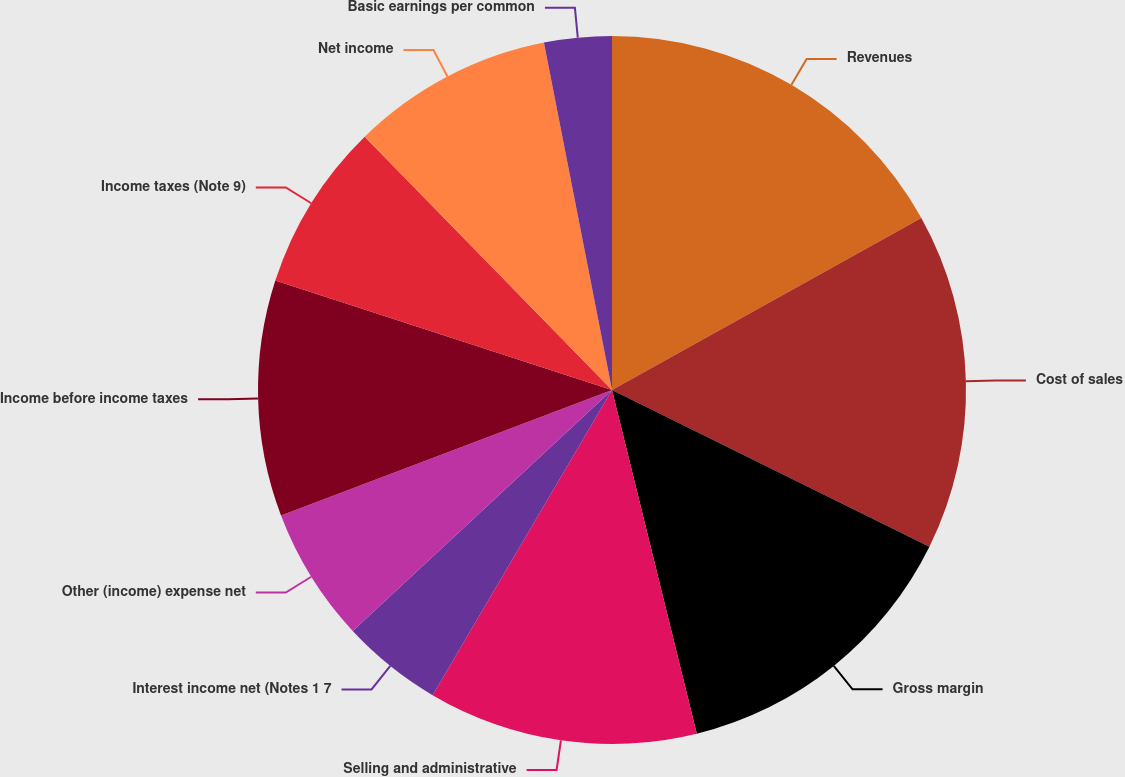Convert chart. <chart><loc_0><loc_0><loc_500><loc_500><pie_chart><fcel>Revenues<fcel>Cost of sales<fcel>Gross margin<fcel>Selling and administrative<fcel>Interest income net (Notes 1 7<fcel>Other (income) expense net<fcel>Income before income taxes<fcel>Income taxes (Note 9)<fcel>Net income<fcel>Basic earnings per common<nl><fcel>16.92%<fcel>15.38%<fcel>13.85%<fcel>12.31%<fcel>4.62%<fcel>6.15%<fcel>10.77%<fcel>7.69%<fcel>9.23%<fcel>3.08%<nl></chart> 